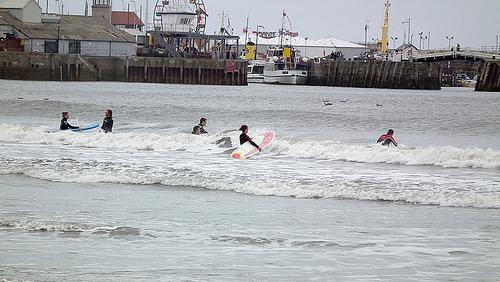Question: how many people can be seen?
Choices:
A. One.
B. Five.
C. Two.
D. Three.
Answer with the letter. Answer: B Question: where is the ferris wheel?
Choices:
A. A the fair.
B. In the sky.
C. On the truck.
D. Behind the people.
Answer with the letter. Answer: D Question: what are the people in?
Choices:
A. Water.
B. Mud.
C. A car.
D. A roller coaster.
Answer with the letter. Answer: A Question: what are the people doing?
Choices:
A. Swimming.
B. Walking.
C. Eating.
D. Surfing.
Answer with the letter. Answer: D Question: who is in the water?
Choices:
A. A dog.
B. A little girl.
C. People.
D. The lifeguard.
Answer with the letter. Answer: C Question: why are they carrying surfboards?
Choices:
A. To sell them.
B. To hide them.
C. To paint them.
D. To surf.
Answer with the letter. Answer: D Question: what are the people carrying?
Choices:
A. Cameras.
B. Surfboards.
C. Backpacks.
D. Umbrellas.
Answer with the letter. Answer: B 